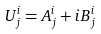<formula> <loc_0><loc_0><loc_500><loc_500>U ^ { i } _ { j } = { A } ^ { i } _ { j } + i { B } ^ { i } _ { j }</formula> 